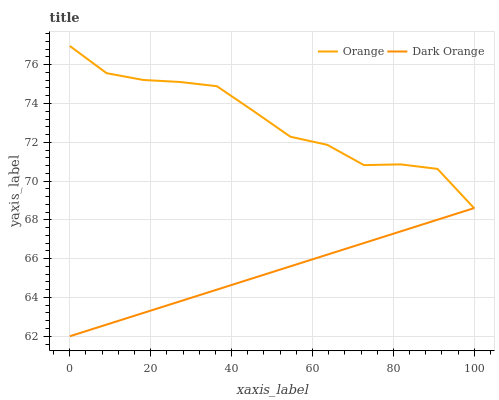Does Dark Orange have the minimum area under the curve?
Answer yes or no. Yes. Does Orange have the maximum area under the curve?
Answer yes or no. Yes. Does Dark Orange have the maximum area under the curve?
Answer yes or no. No. Is Dark Orange the smoothest?
Answer yes or no. Yes. Is Orange the roughest?
Answer yes or no. Yes. Is Dark Orange the roughest?
Answer yes or no. No. Does Dark Orange have the highest value?
Answer yes or no. No. 